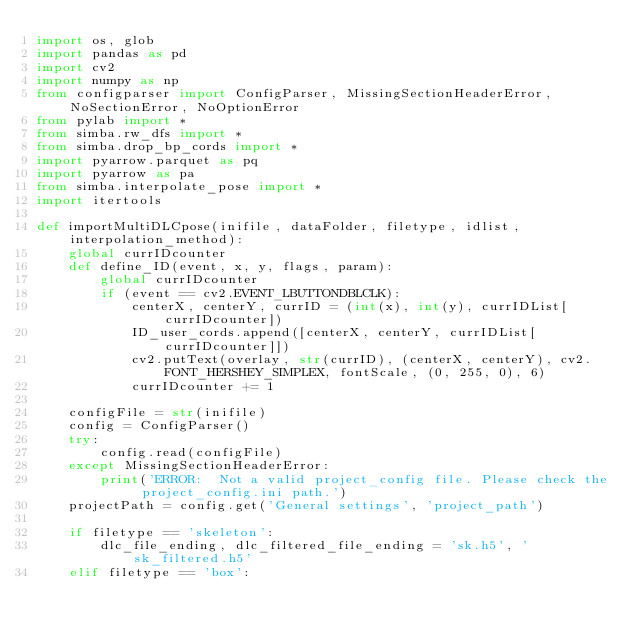Convert code to text. <code><loc_0><loc_0><loc_500><loc_500><_Python_>import os, glob
import pandas as pd
import cv2
import numpy as np
from configparser import ConfigParser, MissingSectionHeaderError, NoSectionError, NoOptionError
from pylab import *
from simba.rw_dfs import *
from simba.drop_bp_cords import *
import pyarrow.parquet as pq
import pyarrow as pa
from simba.interpolate_pose import *
import itertools

def importMultiDLCpose(inifile, dataFolder, filetype, idlist, interpolation_method):
    global currIDcounter
    def define_ID(event, x, y, flags, param):
        global currIDcounter
        if (event == cv2.EVENT_LBUTTONDBLCLK):
            centerX, centerY, currID = (int(x), int(y), currIDList[currIDcounter])
            ID_user_cords.append([centerX, centerY, currIDList[currIDcounter]])
            cv2.putText(overlay, str(currID), (centerX, centerY), cv2.FONT_HERSHEY_SIMPLEX, fontScale, (0, 255, 0), 6)
            currIDcounter += 1

    configFile = str(inifile)
    config = ConfigParser()
    try:
        config.read(configFile)
    except MissingSectionHeaderError:
        print('ERROR:  Not a valid project_config file. Please check the project_config.ini path.')
    projectPath = config.get('General settings', 'project_path')

    if filetype == 'skeleton':
        dlc_file_ending, dlc_filtered_file_ending = 'sk.h5', 'sk_filtered.h5'
    elif filetype == 'box':</code> 